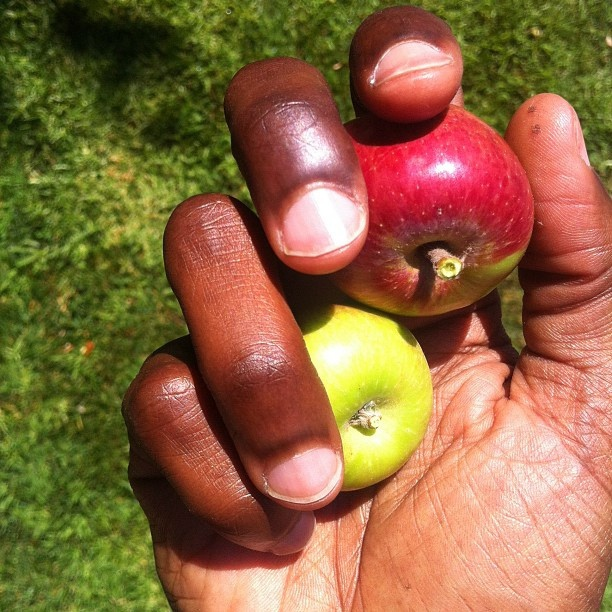Describe the objects in this image and their specific colors. I can see people in black, maroon, and salmon tones, apple in black, maroon, brown, and red tones, and apple in black, yellow, and khaki tones in this image. 